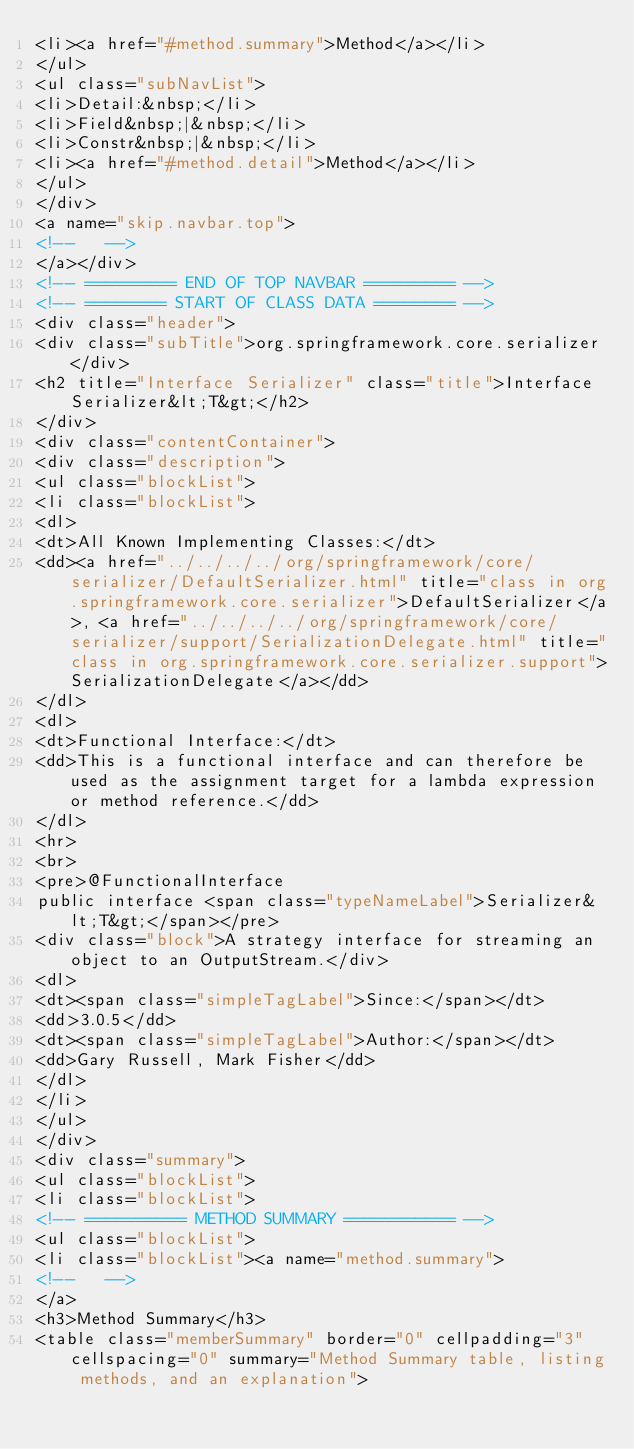Convert code to text. <code><loc_0><loc_0><loc_500><loc_500><_HTML_><li><a href="#method.summary">Method</a></li>
</ul>
<ul class="subNavList">
<li>Detail:&nbsp;</li>
<li>Field&nbsp;|&nbsp;</li>
<li>Constr&nbsp;|&nbsp;</li>
<li><a href="#method.detail">Method</a></li>
</ul>
</div>
<a name="skip.navbar.top">
<!--   -->
</a></div>
<!-- ========= END OF TOP NAVBAR ========= -->
<!-- ======== START OF CLASS DATA ======== -->
<div class="header">
<div class="subTitle">org.springframework.core.serializer</div>
<h2 title="Interface Serializer" class="title">Interface Serializer&lt;T&gt;</h2>
</div>
<div class="contentContainer">
<div class="description">
<ul class="blockList">
<li class="blockList">
<dl>
<dt>All Known Implementing Classes:</dt>
<dd><a href="../../../../org/springframework/core/serializer/DefaultSerializer.html" title="class in org.springframework.core.serializer">DefaultSerializer</a>, <a href="../../../../org/springframework/core/serializer/support/SerializationDelegate.html" title="class in org.springframework.core.serializer.support">SerializationDelegate</a></dd>
</dl>
<dl>
<dt>Functional Interface:</dt>
<dd>This is a functional interface and can therefore be used as the assignment target for a lambda expression or method reference.</dd>
</dl>
<hr>
<br>
<pre>@FunctionalInterface
public interface <span class="typeNameLabel">Serializer&lt;T&gt;</span></pre>
<div class="block">A strategy interface for streaming an object to an OutputStream.</div>
<dl>
<dt><span class="simpleTagLabel">Since:</span></dt>
<dd>3.0.5</dd>
<dt><span class="simpleTagLabel">Author:</span></dt>
<dd>Gary Russell, Mark Fisher</dd>
</dl>
</li>
</ul>
</div>
<div class="summary">
<ul class="blockList">
<li class="blockList">
<!-- ========== METHOD SUMMARY =========== -->
<ul class="blockList">
<li class="blockList"><a name="method.summary">
<!--   -->
</a>
<h3>Method Summary</h3>
<table class="memberSummary" border="0" cellpadding="3" cellspacing="0" summary="Method Summary table, listing methods, and an explanation"></code> 